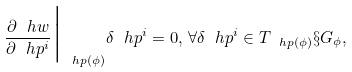Convert formula to latex. <formula><loc_0><loc_0><loc_500><loc_500>\frac { \partial \ h w } { \partial \ h p ^ { i } } { \Big | _ { \ h p ( \phi ) } } \delta \ h p ^ { i } = 0 , \, \forall \delta \ h p ^ { i } \in T _ { \ h p ( \phi ) } \S { G _ { \phi } } ,</formula> 